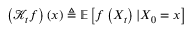Convert formula to latex. <formula><loc_0><loc_0><loc_500><loc_500>\left ( \mathcal { K } _ { t } f \right ) \left ( x \right ) \triangle q \mathbb { E } \left [ f \left ( X _ { t } \right ) | X _ { 0 } = x \right ]</formula> 